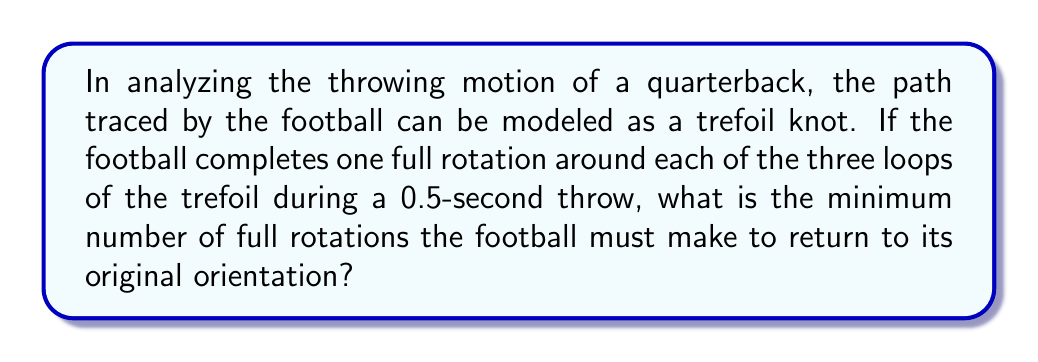Give your solution to this math problem. To solve this problem, we need to understand the properties of the trefoil knot and how they relate to the quarterback's throwing motion:

1. The trefoil knot is the simplest non-trivial knot, with a crossing number of 3.

2. In knot theory, the trefoil knot has a fundamental group that is isomorphic to the braid group $B_3$. The presentation of this group is:

   $$\langle a, b | aba = bab \rangle$$

3. The order of rotational symmetry for a trefoil knot is 3. This means that after three full rotations around the knot, an object would return to its original orientation.

4. In our scenario, the football completes one full rotation for each loop of the trefoil during the 0.5-second throw. There are three loops in a trefoil knot.

5. To find the minimum number of full rotations needed to return to the original orientation, we need to find the least common multiple (LCM) of the number of loops (3) and the order of rotational symmetry (3).

6. LCM(3,3) = 3

Therefore, the football must complete at least 3 full rotations around the entire trefoil knot to return to its original orientation.

7. Since each throw involves 3 rotations (one for each loop), the minimum number of throws required is:

   $$\frac{3 \text{ (total rotations needed)}}{3 \text{ (rotations per throw)}} = 1 \text{ throw}$$

Thus, the football returns to its original orientation after just one complete throw following the trefoil knot path.
Answer: 3 rotations 